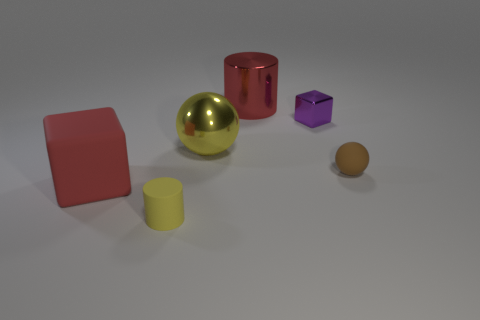There is a metal thing left of the big red object that is behind the tiny shiny thing; how big is it?
Provide a succinct answer. Large. Does the big yellow shiny thing have the same shape as the purple metallic thing?
Make the answer very short. No. Does the red thing left of the red metal cylinder have the same size as the cylinder that is left of the big red metallic cylinder?
Your answer should be compact. No. There is a large thing that is the same color as the large shiny cylinder; what is its material?
Your response must be concise. Rubber. Is there any other thing that is the same shape as the purple metallic object?
Ensure brevity in your answer.  Yes. There is a big red object that is on the left side of the large yellow ball; what is its material?
Your response must be concise. Rubber. Are there any big shiny things in front of the tiny metal cube?
Your answer should be compact. Yes. What is the shape of the large red matte thing?
Provide a short and direct response. Cube. How many objects are small things to the right of the yellow shiny sphere or small rubber balls?
Your response must be concise. 2. What number of other objects are there of the same color as the metal cylinder?
Offer a terse response. 1. 